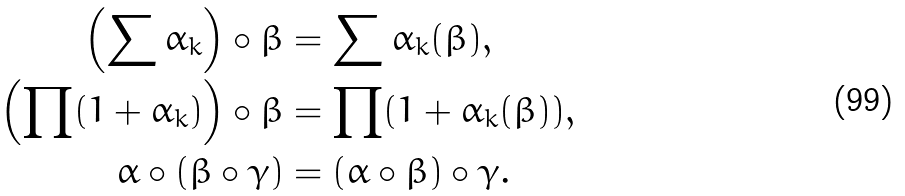Convert formula to latex. <formula><loc_0><loc_0><loc_500><loc_500>\left ( \sum \alpha _ { k } \right ) \circ \beta & = \sum \alpha _ { k } ( \beta ) , \\ \left ( \prod ( 1 + \alpha _ { k } ) \right ) \circ \beta & = \prod ( 1 + \alpha _ { k } ( \beta ) ) , \\ \alpha \circ ( \beta \circ \gamma ) & = ( \alpha \circ \beta ) \circ \gamma .</formula> 